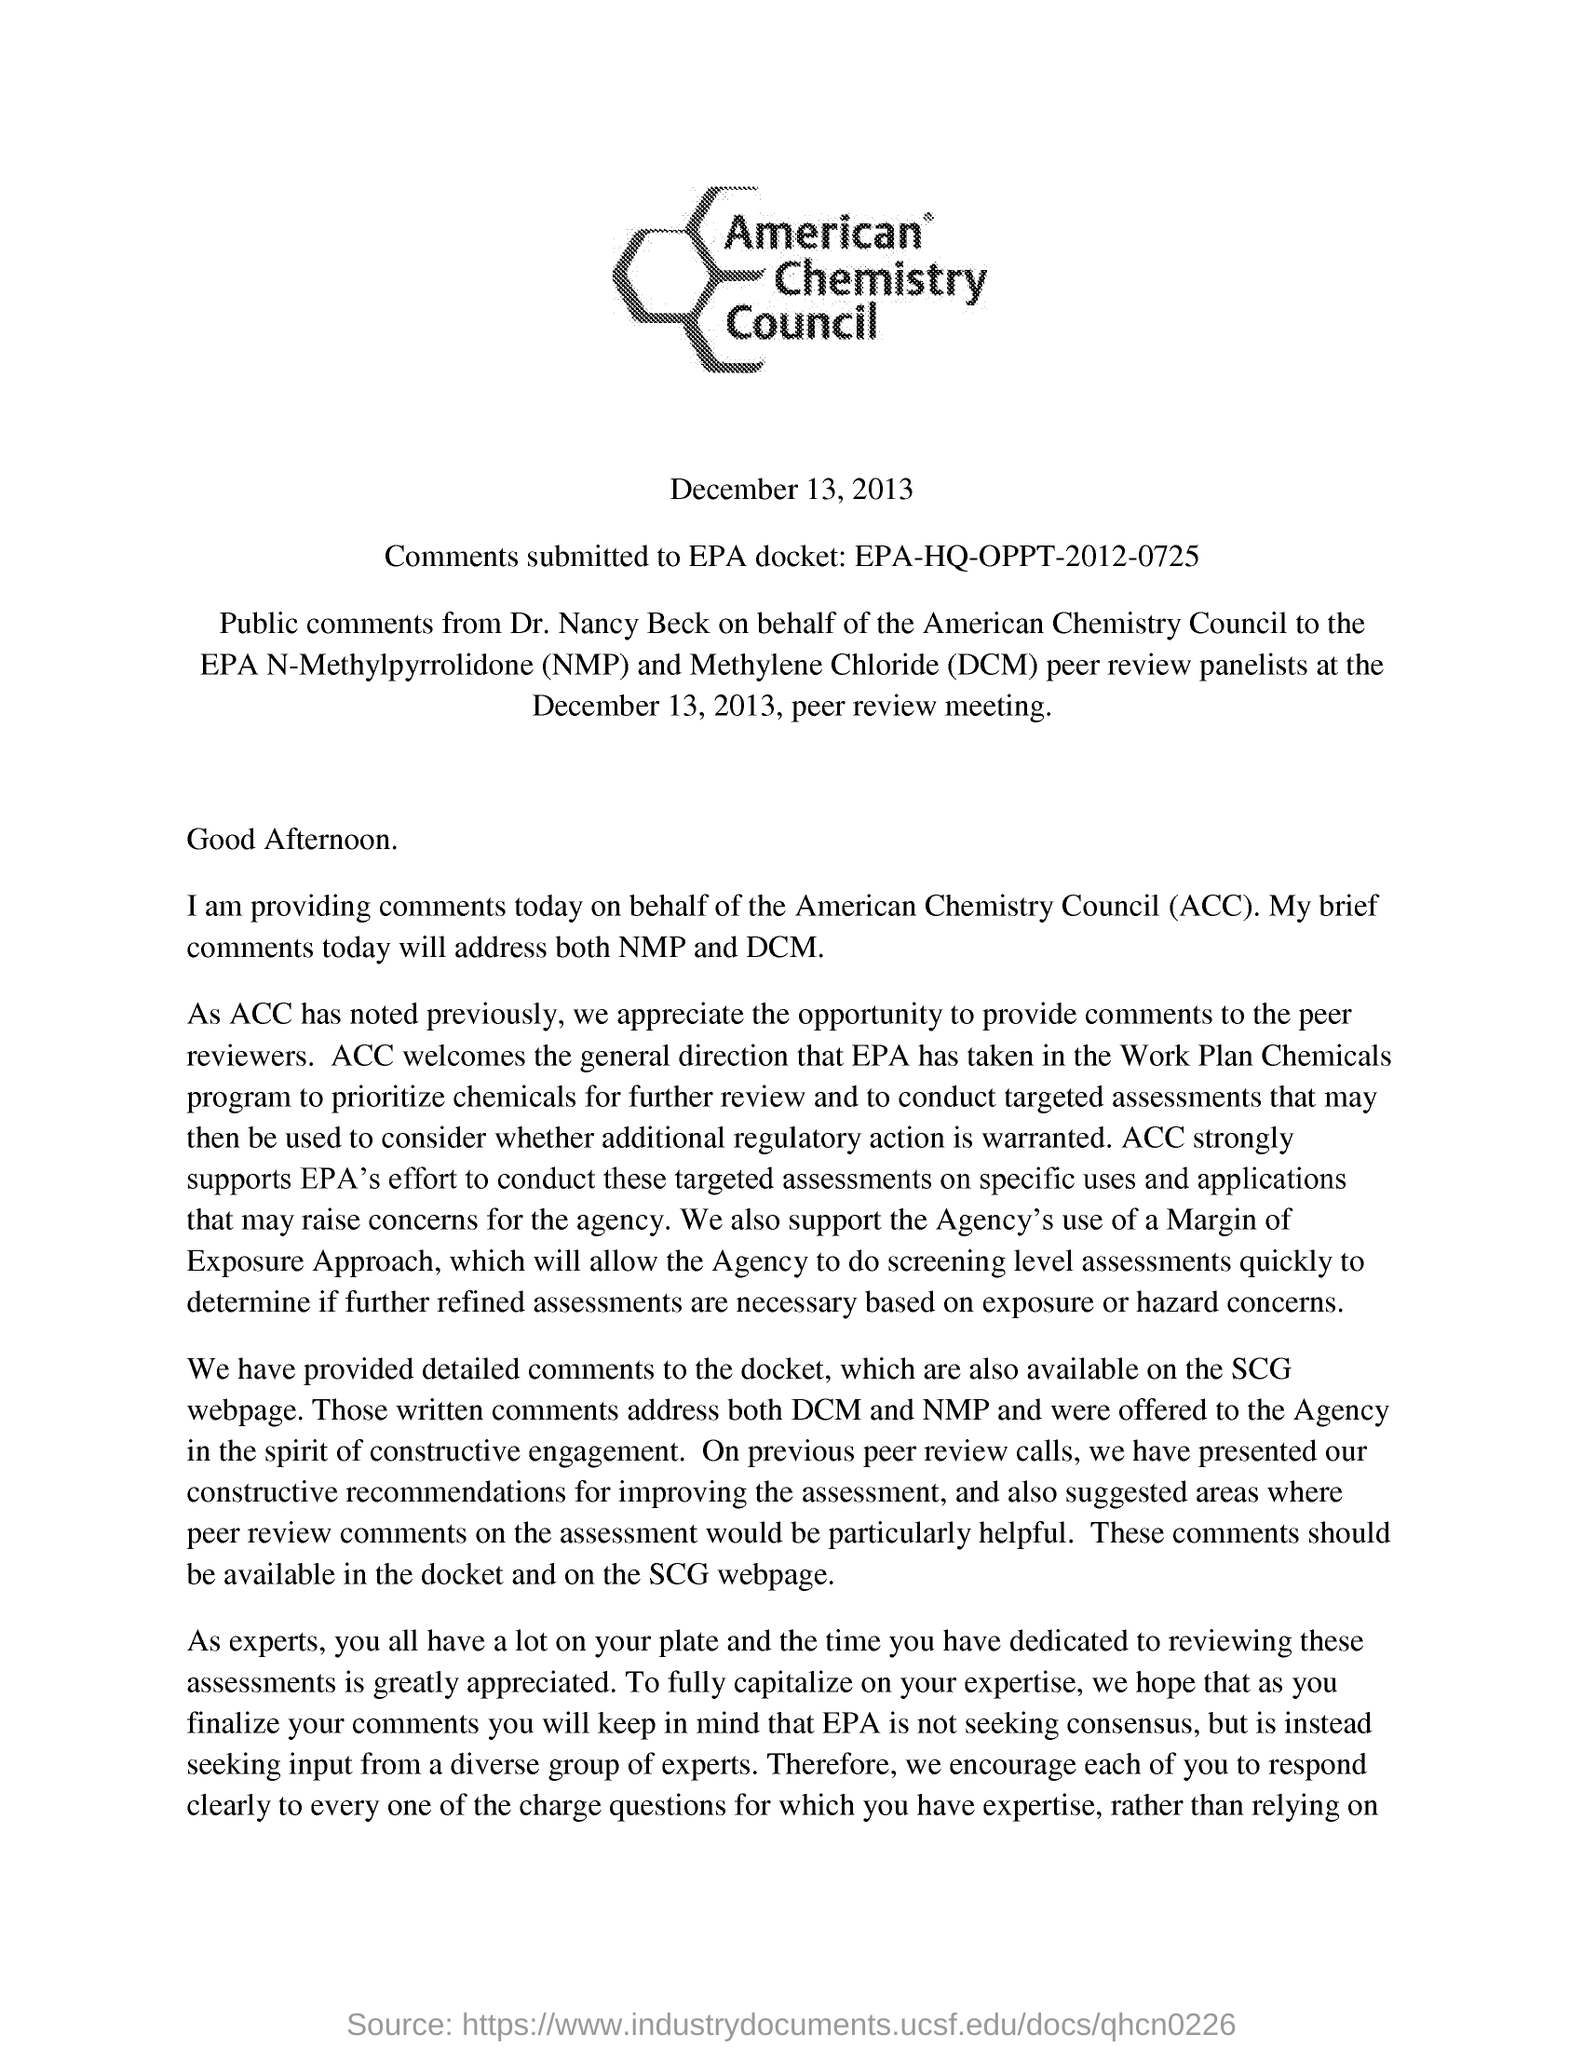What is the council name?
Offer a very short reply. American chemistry. What is the date of peer review meeting?
Give a very brief answer. December 13, 2013. What is the comments subbmitted EPA docket ID?
Make the answer very short. EPA-HQ-OPPT-2012-0725. Public comments are submitted by whom?
Provide a short and direct response. DR. NANCY BECK. On behalf of whom Dr. nancy Beck submitted the public comments?
Keep it short and to the point. American Chemistry Council. What does ACC stand for?
Your answer should be very brief. American Chemistry council. Where is the comments also available at?
Your answer should be compact. SCG WEBPAGE. What does the comments address?
Provide a short and direct response. NMP and DCM. 